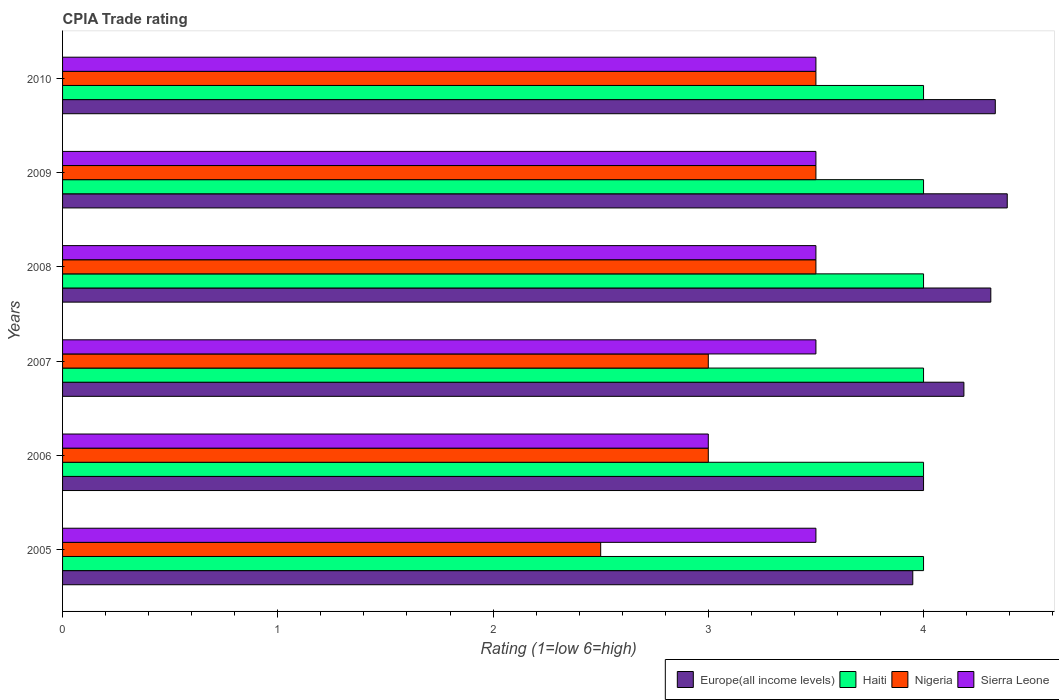How many groups of bars are there?
Your answer should be compact. 6. How many bars are there on the 6th tick from the bottom?
Make the answer very short. 4. What is the CPIA rating in Sierra Leone in 2007?
Your answer should be very brief. 3.5. Across all years, what is the maximum CPIA rating in Sierra Leone?
Your answer should be compact. 3.5. Across all years, what is the minimum CPIA rating in Haiti?
Make the answer very short. 4. In which year was the CPIA rating in Europe(all income levels) maximum?
Offer a very short reply. 2009. What is the total CPIA rating in Europe(all income levels) in the graph?
Keep it short and to the point. 25.17. What is the difference between the CPIA rating in Haiti in 2008 and that in 2009?
Provide a short and direct response. 0. What is the difference between the CPIA rating in Haiti in 2006 and the CPIA rating in Sierra Leone in 2009?
Keep it short and to the point. 0.5. What is the average CPIA rating in Europe(all income levels) per year?
Give a very brief answer. 4.2. In the year 2009, what is the difference between the CPIA rating in Nigeria and CPIA rating in Europe(all income levels)?
Give a very brief answer. -0.89. In how many years, is the CPIA rating in Haiti greater than 2 ?
Keep it short and to the point. 6. What is the ratio of the CPIA rating in Nigeria in 2007 to that in 2010?
Provide a short and direct response. 0.86. Is the CPIA rating in Haiti in 2006 less than that in 2007?
Ensure brevity in your answer.  No. Is the difference between the CPIA rating in Nigeria in 2006 and 2010 greater than the difference between the CPIA rating in Europe(all income levels) in 2006 and 2010?
Make the answer very short. No. What is the difference between the highest and the second highest CPIA rating in Sierra Leone?
Provide a succinct answer. 0. What is the difference between the highest and the lowest CPIA rating in Europe(all income levels)?
Provide a short and direct response. 0.44. Is the sum of the CPIA rating in Haiti in 2005 and 2006 greater than the maximum CPIA rating in Europe(all income levels) across all years?
Ensure brevity in your answer.  Yes. What does the 4th bar from the top in 2009 represents?
Offer a very short reply. Europe(all income levels). What does the 3rd bar from the bottom in 2010 represents?
Your response must be concise. Nigeria. Is it the case that in every year, the sum of the CPIA rating in Haiti and CPIA rating in Nigeria is greater than the CPIA rating in Europe(all income levels)?
Give a very brief answer. Yes. Are all the bars in the graph horizontal?
Offer a very short reply. Yes. How many years are there in the graph?
Offer a very short reply. 6. What is the difference between two consecutive major ticks on the X-axis?
Ensure brevity in your answer.  1. Are the values on the major ticks of X-axis written in scientific E-notation?
Provide a succinct answer. No. Does the graph contain any zero values?
Ensure brevity in your answer.  No. Where does the legend appear in the graph?
Ensure brevity in your answer.  Bottom right. What is the title of the graph?
Your response must be concise. CPIA Trade rating. Does "Latvia" appear as one of the legend labels in the graph?
Offer a very short reply. No. What is the Rating (1=low 6=high) in Europe(all income levels) in 2005?
Make the answer very short. 3.95. What is the Rating (1=low 6=high) of Europe(all income levels) in 2006?
Give a very brief answer. 4. What is the Rating (1=low 6=high) of Nigeria in 2006?
Your response must be concise. 3. What is the Rating (1=low 6=high) of Sierra Leone in 2006?
Make the answer very short. 3. What is the Rating (1=low 6=high) in Europe(all income levels) in 2007?
Offer a terse response. 4.19. What is the Rating (1=low 6=high) in Haiti in 2007?
Your answer should be very brief. 4. What is the Rating (1=low 6=high) of Sierra Leone in 2007?
Keep it short and to the point. 3.5. What is the Rating (1=low 6=high) in Europe(all income levels) in 2008?
Provide a succinct answer. 4.31. What is the Rating (1=low 6=high) in Nigeria in 2008?
Your response must be concise. 3.5. What is the Rating (1=low 6=high) in Europe(all income levels) in 2009?
Keep it short and to the point. 4.39. What is the Rating (1=low 6=high) in Sierra Leone in 2009?
Your answer should be compact. 3.5. What is the Rating (1=low 6=high) of Europe(all income levels) in 2010?
Make the answer very short. 4.33. What is the Rating (1=low 6=high) in Haiti in 2010?
Your answer should be very brief. 4. What is the Rating (1=low 6=high) of Nigeria in 2010?
Keep it short and to the point. 3.5. What is the Rating (1=low 6=high) in Sierra Leone in 2010?
Ensure brevity in your answer.  3.5. Across all years, what is the maximum Rating (1=low 6=high) of Europe(all income levels)?
Make the answer very short. 4.39. Across all years, what is the maximum Rating (1=low 6=high) in Sierra Leone?
Give a very brief answer. 3.5. Across all years, what is the minimum Rating (1=low 6=high) of Europe(all income levels)?
Your response must be concise. 3.95. Across all years, what is the minimum Rating (1=low 6=high) in Nigeria?
Give a very brief answer. 2.5. Across all years, what is the minimum Rating (1=low 6=high) in Sierra Leone?
Offer a terse response. 3. What is the total Rating (1=low 6=high) in Europe(all income levels) in the graph?
Your response must be concise. 25.17. What is the difference between the Rating (1=low 6=high) in Haiti in 2005 and that in 2006?
Keep it short and to the point. 0. What is the difference between the Rating (1=low 6=high) of Nigeria in 2005 and that in 2006?
Give a very brief answer. -0.5. What is the difference between the Rating (1=low 6=high) in Europe(all income levels) in 2005 and that in 2007?
Give a very brief answer. -0.24. What is the difference between the Rating (1=low 6=high) in Haiti in 2005 and that in 2007?
Keep it short and to the point. 0. What is the difference between the Rating (1=low 6=high) of Europe(all income levels) in 2005 and that in 2008?
Offer a very short reply. -0.36. What is the difference between the Rating (1=low 6=high) of Haiti in 2005 and that in 2008?
Offer a terse response. 0. What is the difference between the Rating (1=low 6=high) in Sierra Leone in 2005 and that in 2008?
Keep it short and to the point. 0. What is the difference between the Rating (1=low 6=high) of Europe(all income levels) in 2005 and that in 2009?
Offer a terse response. -0.44. What is the difference between the Rating (1=low 6=high) in Nigeria in 2005 and that in 2009?
Your answer should be compact. -1. What is the difference between the Rating (1=low 6=high) in Europe(all income levels) in 2005 and that in 2010?
Provide a succinct answer. -0.38. What is the difference between the Rating (1=low 6=high) in Sierra Leone in 2005 and that in 2010?
Your response must be concise. 0. What is the difference between the Rating (1=low 6=high) in Europe(all income levels) in 2006 and that in 2007?
Offer a terse response. -0.19. What is the difference between the Rating (1=low 6=high) in Haiti in 2006 and that in 2007?
Keep it short and to the point. 0. What is the difference between the Rating (1=low 6=high) of Nigeria in 2006 and that in 2007?
Keep it short and to the point. 0. What is the difference between the Rating (1=low 6=high) of Sierra Leone in 2006 and that in 2007?
Your response must be concise. -0.5. What is the difference between the Rating (1=low 6=high) in Europe(all income levels) in 2006 and that in 2008?
Ensure brevity in your answer.  -0.31. What is the difference between the Rating (1=low 6=high) in Haiti in 2006 and that in 2008?
Offer a very short reply. 0. What is the difference between the Rating (1=low 6=high) of Europe(all income levels) in 2006 and that in 2009?
Give a very brief answer. -0.39. What is the difference between the Rating (1=low 6=high) in Haiti in 2006 and that in 2009?
Your response must be concise. 0. What is the difference between the Rating (1=low 6=high) in Europe(all income levels) in 2007 and that in 2008?
Ensure brevity in your answer.  -0.12. What is the difference between the Rating (1=low 6=high) of Haiti in 2007 and that in 2008?
Provide a succinct answer. 0. What is the difference between the Rating (1=low 6=high) in Sierra Leone in 2007 and that in 2008?
Offer a terse response. 0. What is the difference between the Rating (1=low 6=high) of Europe(all income levels) in 2007 and that in 2009?
Make the answer very short. -0.2. What is the difference between the Rating (1=low 6=high) of Nigeria in 2007 and that in 2009?
Provide a short and direct response. -0.5. What is the difference between the Rating (1=low 6=high) in Europe(all income levels) in 2007 and that in 2010?
Offer a terse response. -0.15. What is the difference between the Rating (1=low 6=high) of Haiti in 2007 and that in 2010?
Make the answer very short. 0. What is the difference between the Rating (1=low 6=high) in Nigeria in 2007 and that in 2010?
Your response must be concise. -0.5. What is the difference between the Rating (1=low 6=high) of Europe(all income levels) in 2008 and that in 2009?
Provide a succinct answer. -0.08. What is the difference between the Rating (1=low 6=high) of Haiti in 2008 and that in 2009?
Make the answer very short. 0. What is the difference between the Rating (1=low 6=high) of Nigeria in 2008 and that in 2009?
Ensure brevity in your answer.  0. What is the difference between the Rating (1=low 6=high) in Sierra Leone in 2008 and that in 2009?
Ensure brevity in your answer.  0. What is the difference between the Rating (1=low 6=high) of Europe(all income levels) in 2008 and that in 2010?
Make the answer very short. -0.02. What is the difference between the Rating (1=low 6=high) in Nigeria in 2008 and that in 2010?
Your answer should be compact. 0. What is the difference between the Rating (1=low 6=high) in Europe(all income levels) in 2009 and that in 2010?
Ensure brevity in your answer.  0.06. What is the difference between the Rating (1=low 6=high) in Haiti in 2009 and that in 2010?
Your answer should be compact. 0. What is the difference between the Rating (1=low 6=high) of Nigeria in 2009 and that in 2010?
Give a very brief answer. 0. What is the difference between the Rating (1=low 6=high) of Europe(all income levels) in 2005 and the Rating (1=low 6=high) of Haiti in 2006?
Your answer should be very brief. -0.05. What is the difference between the Rating (1=low 6=high) of Europe(all income levels) in 2005 and the Rating (1=low 6=high) of Nigeria in 2006?
Your response must be concise. 0.95. What is the difference between the Rating (1=low 6=high) in Haiti in 2005 and the Rating (1=low 6=high) in Nigeria in 2006?
Keep it short and to the point. 1. What is the difference between the Rating (1=low 6=high) in Haiti in 2005 and the Rating (1=low 6=high) in Sierra Leone in 2006?
Your response must be concise. 1. What is the difference between the Rating (1=low 6=high) in Europe(all income levels) in 2005 and the Rating (1=low 6=high) in Nigeria in 2007?
Your answer should be very brief. 0.95. What is the difference between the Rating (1=low 6=high) in Europe(all income levels) in 2005 and the Rating (1=low 6=high) in Sierra Leone in 2007?
Offer a very short reply. 0.45. What is the difference between the Rating (1=low 6=high) in Europe(all income levels) in 2005 and the Rating (1=low 6=high) in Nigeria in 2008?
Your answer should be compact. 0.45. What is the difference between the Rating (1=low 6=high) of Europe(all income levels) in 2005 and the Rating (1=low 6=high) of Sierra Leone in 2008?
Give a very brief answer. 0.45. What is the difference between the Rating (1=low 6=high) of Haiti in 2005 and the Rating (1=low 6=high) of Nigeria in 2008?
Give a very brief answer. 0.5. What is the difference between the Rating (1=low 6=high) of Haiti in 2005 and the Rating (1=low 6=high) of Sierra Leone in 2008?
Keep it short and to the point. 0.5. What is the difference between the Rating (1=low 6=high) of Nigeria in 2005 and the Rating (1=low 6=high) of Sierra Leone in 2008?
Give a very brief answer. -1. What is the difference between the Rating (1=low 6=high) in Europe(all income levels) in 2005 and the Rating (1=low 6=high) in Nigeria in 2009?
Offer a terse response. 0.45. What is the difference between the Rating (1=low 6=high) in Europe(all income levels) in 2005 and the Rating (1=low 6=high) in Sierra Leone in 2009?
Offer a terse response. 0.45. What is the difference between the Rating (1=low 6=high) in Haiti in 2005 and the Rating (1=low 6=high) in Nigeria in 2009?
Provide a short and direct response. 0.5. What is the difference between the Rating (1=low 6=high) of Haiti in 2005 and the Rating (1=low 6=high) of Sierra Leone in 2009?
Provide a succinct answer. 0.5. What is the difference between the Rating (1=low 6=high) of Nigeria in 2005 and the Rating (1=low 6=high) of Sierra Leone in 2009?
Provide a succinct answer. -1. What is the difference between the Rating (1=low 6=high) of Europe(all income levels) in 2005 and the Rating (1=low 6=high) of Nigeria in 2010?
Make the answer very short. 0.45. What is the difference between the Rating (1=low 6=high) in Europe(all income levels) in 2005 and the Rating (1=low 6=high) in Sierra Leone in 2010?
Your answer should be very brief. 0.45. What is the difference between the Rating (1=low 6=high) in Haiti in 2005 and the Rating (1=low 6=high) in Nigeria in 2010?
Your answer should be very brief. 0.5. What is the difference between the Rating (1=low 6=high) of Nigeria in 2005 and the Rating (1=low 6=high) of Sierra Leone in 2010?
Your answer should be compact. -1. What is the difference between the Rating (1=low 6=high) of Europe(all income levels) in 2006 and the Rating (1=low 6=high) of Nigeria in 2007?
Your response must be concise. 1. What is the difference between the Rating (1=low 6=high) of Europe(all income levels) in 2006 and the Rating (1=low 6=high) of Sierra Leone in 2007?
Ensure brevity in your answer.  0.5. What is the difference between the Rating (1=low 6=high) in Haiti in 2006 and the Rating (1=low 6=high) in Nigeria in 2007?
Offer a terse response. 1. What is the difference between the Rating (1=low 6=high) of Nigeria in 2006 and the Rating (1=low 6=high) of Sierra Leone in 2007?
Your answer should be very brief. -0.5. What is the difference between the Rating (1=low 6=high) of Europe(all income levels) in 2006 and the Rating (1=low 6=high) of Sierra Leone in 2008?
Your answer should be compact. 0.5. What is the difference between the Rating (1=low 6=high) of Haiti in 2006 and the Rating (1=low 6=high) of Sierra Leone in 2008?
Offer a very short reply. 0.5. What is the difference between the Rating (1=low 6=high) in Nigeria in 2006 and the Rating (1=low 6=high) in Sierra Leone in 2008?
Your answer should be very brief. -0.5. What is the difference between the Rating (1=low 6=high) in Europe(all income levels) in 2006 and the Rating (1=low 6=high) in Nigeria in 2009?
Ensure brevity in your answer.  0.5. What is the difference between the Rating (1=low 6=high) in Haiti in 2006 and the Rating (1=low 6=high) in Nigeria in 2009?
Provide a short and direct response. 0.5. What is the difference between the Rating (1=low 6=high) of Haiti in 2006 and the Rating (1=low 6=high) of Sierra Leone in 2009?
Provide a succinct answer. 0.5. What is the difference between the Rating (1=low 6=high) of Nigeria in 2006 and the Rating (1=low 6=high) of Sierra Leone in 2009?
Provide a short and direct response. -0.5. What is the difference between the Rating (1=low 6=high) in Europe(all income levels) in 2006 and the Rating (1=low 6=high) in Haiti in 2010?
Keep it short and to the point. 0. What is the difference between the Rating (1=low 6=high) in Haiti in 2006 and the Rating (1=low 6=high) in Nigeria in 2010?
Provide a short and direct response. 0.5. What is the difference between the Rating (1=low 6=high) in Europe(all income levels) in 2007 and the Rating (1=low 6=high) in Haiti in 2008?
Your response must be concise. 0.19. What is the difference between the Rating (1=low 6=high) of Europe(all income levels) in 2007 and the Rating (1=low 6=high) of Nigeria in 2008?
Ensure brevity in your answer.  0.69. What is the difference between the Rating (1=low 6=high) in Europe(all income levels) in 2007 and the Rating (1=low 6=high) in Sierra Leone in 2008?
Offer a very short reply. 0.69. What is the difference between the Rating (1=low 6=high) of Haiti in 2007 and the Rating (1=low 6=high) of Nigeria in 2008?
Make the answer very short. 0.5. What is the difference between the Rating (1=low 6=high) of Haiti in 2007 and the Rating (1=low 6=high) of Sierra Leone in 2008?
Your response must be concise. 0.5. What is the difference between the Rating (1=low 6=high) of Nigeria in 2007 and the Rating (1=low 6=high) of Sierra Leone in 2008?
Your answer should be compact. -0.5. What is the difference between the Rating (1=low 6=high) in Europe(all income levels) in 2007 and the Rating (1=low 6=high) in Haiti in 2009?
Ensure brevity in your answer.  0.19. What is the difference between the Rating (1=low 6=high) in Europe(all income levels) in 2007 and the Rating (1=low 6=high) in Nigeria in 2009?
Keep it short and to the point. 0.69. What is the difference between the Rating (1=low 6=high) of Europe(all income levels) in 2007 and the Rating (1=low 6=high) of Sierra Leone in 2009?
Offer a terse response. 0.69. What is the difference between the Rating (1=low 6=high) of Haiti in 2007 and the Rating (1=low 6=high) of Nigeria in 2009?
Your answer should be very brief. 0.5. What is the difference between the Rating (1=low 6=high) of Haiti in 2007 and the Rating (1=low 6=high) of Sierra Leone in 2009?
Ensure brevity in your answer.  0.5. What is the difference between the Rating (1=low 6=high) of Nigeria in 2007 and the Rating (1=low 6=high) of Sierra Leone in 2009?
Your answer should be very brief. -0.5. What is the difference between the Rating (1=low 6=high) of Europe(all income levels) in 2007 and the Rating (1=low 6=high) of Haiti in 2010?
Offer a very short reply. 0.19. What is the difference between the Rating (1=low 6=high) in Europe(all income levels) in 2007 and the Rating (1=low 6=high) in Nigeria in 2010?
Make the answer very short. 0.69. What is the difference between the Rating (1=low 6=high) in Europe(all income levels) in 2007 and the Rating (1=low 6=high) in Sierra Leone in 2010?
Ensure brevity in your answer.  0.69. What is the difference between the Rating (1=low 6=high) in Haiti in 2007 and the Rating (1=low 6=high) in Nigeria in 2010?
Your answer should be very brief. 0.5. What is the difference between the Rating (1=low 6=high) in Nigeria in 2007 and the Rating (1=low 6=high) in Sierra Leone in 2010?
Your answer should be very brief. -0.5. What is the difference between the Rating (1=low 6=high) of Europe(all income levels) in 2008 and the Rating (1=low 6=high) of Haiti in 2009?
Your answer should be very brief. 0.31. What is the difference between the Rating (1=low 6=high) in Europe(all income levels) in 2008 and the Rating (1=low 6=high) in Nigeria in 2009?
Offer a very short reply. 0.81. What is the difference between the Rating (1=low 6=high) in Europe(all income levels) in 2008 and the Rating (1=low 6=high) in Sierra Leone in 2009?
Provide a succinct answer. 0.81. What is the difference between the Rating (1=low 6=high) in Haiti in 2008 and the Rating (1=low 6=high) in Nigeria in 2009?
Keep it short and to the point. 0.5. What is the difference between the Rating (1=low 6=high) in Nigeria in 2008 and the Rating (1=low 6=high) in Sierra Leone in 2009?
Your answer should be compact. 0. What is the difference between the Rating (1=low 6=high) of Europe(all income levels) in 2008 and the Rating (1=low 6=high) of Haiti in 2010?
Give a very brief answer. 0.31. What is the difference between the Rating (1=low 6=high) in Europe(all income levels) in 2008 and the Rating (1=low 6=high) in Nigeria in 2010?
Your answer should be very brief. 0.81. What is the difference between the Rating (1=low 6=high) of Europe(all income levels) in 2008 and the Rating (1=low 6=high) of Sierra Leone in 2010?
Make the answer very short. 0.81. What is the difference between the Rating (1=low 6=high) in Haiti in 2008 and the Rating (1=low 6=high) in Sierra Leone in 2010?
Give a very brief answer. 0.5. What is the difference between the Rating (1=low 6=high) in Nigeria in 2008 and the Rating (1=low 6=high) in Sierra Leone in 2010?
Your response must be concise. 0. What is the difference between the Rating (1=low 6=high) of Europe(all income levels) in 2009 and the Rating (1=low 6=high) of Haiti in 2010?
Your response must be concise. 0.39. What is the difference between the Rating (1=low 6=high) in Europe(all income levels) in 2009 and the Rating (1=low 6=high) in Nigeria in 2010?
Your response must be concise. 0.89. What is the difference between the Rating (1=low 6=high) of Europe(all income levels) in 2009 and the Rating (1=low 6=high) of Sierra Leone in 2010?
Ensure brevity in your answer.  0.89. What is the difference between the Rating (1=low 6=high) of Haiti in 2009 and the Rating (1=low 6=high) of Nigeria in 2010?
Offer a very short reply. 0.5. What is the difference between the Rating (1=low 6=high) in Haiti in 2009 and the Rating (1=low 6=high) in Sierra Leone in 2010?
Provide a succinct answer. 0.5. What is the average Rating (1=low 6=high) in Europe(all income levels) per year?
Your response must be concise. 4.2. What is the average Rating (1=low 6=high) in Nigeria per year?
Offer a very short reply. 3.17. What is the average Rating (1=low 6=high) of Sierra Leone per year?
Your answer should be compact. 3.42. In the year 2005, what is the difference between the Rating (1=low 6=high) of Europe(all income levels) and Rating (1=low 6=high) of Nigeria?
Your answer should be very brief. 1.45. In the year 2005, what is the difference between the Rating (1=low 6=high) in Europe(all income levels) and Rating (1=low 6=high) in Sierra Leone?
Provide a succinct answer. 0.45. In the year 2005, what is the difference between the Rating (1=low 6=high) in Haiti and Rating (1=low 6=high) in Nigeria?
Your response must be concise. 1.5. In the year 2005, what is the difference between the Rating (1=low 6=high) in Nigeria and Rating (1=low 6=high) in Sierra Leone?
Your answer should be compact. -1. In the year 2006, what is the difference between the Rating (1=low 6=high) of Europe(all income levels) and Rating (1=low 6=high) of Nigeria?
Give a very brief answer. 1. In the year 2006, what is the difference between the Rating (1=low 6=high) of Haiti and Rating (1=low 6=high) of Sierra Leone?
Your answer should be compact. 1. In the year 2007, what is the difference between the Rating (1=low 6=high) of Europe(all income levels) and Rating (1=low 6=high) of Haiti?
Provide a short and direct response. 0.19. In the year 2007, what is the difference between the Rating (1=low 6=high) of Europe(all income levels) and Rating (1=low 6=high) of Nigeria?
Your answer should be very brief. 1.19. In the year 2007, what is the difference between the Rating (1=low 6=high) in Europe(all income levels) and Rating (1=low 6=high) in Sierra Leone?
Provide a succinct answer. 0.69. In the year 2007, what is the difference between the Rating (1=low 6=high) of Haiti and Rating (1=low 6=high) of Sierra Leone?
Keep it short and to the point. 0.5. In the year 2008, what is the difference between the Rating (1=low 6=high) in Europe(all income levels) and Rating (1=low 6=high) in Haiti?
Keep it short and to the point. 0.31. In the year 2008, what is the difference between the Rating (1=low 6=high) of Europe(all income levels) and Rating (1=low 6=high) of Nigeria?
Offer a terse response. 0.81. In the year 2008, what is the difference between the Rating (1=low 6=high) in Europe(all income levels) and Rating (1=low 6=high) in Sierra Leone?
Provide a short and direct response. 0.81. In the year 2008, what is the difference between the Rating (1=low 6=high) in Haiti and Rating (1=low 6=high) in Nigeria?
Give a very brief answer. 0.5. In the year 2009, what is the difference between the Rating (1=low 6=high) of Europe(all income levels) and Rating (1=low 6=high) of Haiti?
Offer a very short reply. 0.39. In the year 2009, what is the difference between the Rating (1=low 6=high) in Europe(all income levels) and Rating (1=low 6=high) in Sierra Leone?
Make the answer very short. 0.89. In the year 2009, what is the difference between the Rating (1=low 6=high) in Nigeria and Rating (1=low 6=high) in Sierra Leone?
Provide a short and direct response. 0. In the year 2010, what is the difference between the Rating (1=low 6=high) in Europe(all income levels) and Rating (1=low 6=high) in Haiti?
Ensure brevity in your answer.  0.33. In the year 2010, what is the difference between the Rating (1=low 6=high) of Nigeria and Rating (1=low 6=high) of Sierra Leone?
Offer a very short reply. 0. What is the ratio of the Rating (1=low 6=high) of Europe(all income levels) in 2005 to that in 2006?
Ensure brevity in your answer.  0.99. What is the ratio of the Rating (1=low 6=high) in Haiti in 2005 to that in 2006?
Your answer should be compact. 1. What is the ratio of the Rating (1=low 6=high) of Nigeria in 2005 to that in 2006?
Keep it short and to the point. 0.83. What is the ratio of the Rating (1=low 6=high) in Sierra Leone in 2005 to that in 2006?
Your response must be concise. 1.17. What is the ratio of the Rating (1=low 6=high) of Europe(all income levels) in 2005 to that in 2007?
Make the answer very short. 0.94. What is the ratio of the Rating (1=low 6=high) in Haiti in 2005 to that in 2007?
Provide a succinct answer. 1. What is the ratio of the Rating (1=low 6=high) of Europe(all income levels) in 2005 to that in 2008?
Make the answer very short. 0.92. What is the ratio of the Rating (1=low 6=high) in Haiti in 2005 to that in 2008?
Offer a very short reply. 1. What is the ratio of the Rating (1=low 6=high) in Sierra Leone in 2005 to that in 2008?
Your response must be concise. 1. What is the ratio of the Rating (1=low 6=high) in Europe(all income levels) in 2005 to that in 2009?
Provide a succinct answer. 0.9. What is the ratio of the Rating (1=low 6=high) of Nigeria in 2005 to that in 2009?
Give a very brief answer. 0.71. What is the ratio of the Rating (1=low 6=high) in Europe(all income levels) in 2005 to that in 2010?
Provide a succinct answer. 0.91. What is the ratio of the Rating (1=low 6=high) in Haiti in 2005 to that in 2010?
Your response must be concise. 1. What is the ratio of the Rating (1=low 6=high) in Nigeria in 2005 to that in 2010?
Make the answer very short. 0.71. What is the ratio of the Rating (1=low 6=high) in Sierra Leone in 2005 to that in 2010?
Offer a terse response. 1. What is the ratio of the Rating (1=low 6=high) in Europe(all income levels) in 2006 to that in 2007?
Give a very brief answer. 0.96. What is the ratio of the Rating (1=low 6=high) in Haiti in 2006 to that in 2007?
Your answer should be very brief. 1. What is the ratio of the Rating (1=low 6=high) in Nigeria in 2006 to that in 2007?
Offer a very short reply. 1. What is the ratio of the Rating (1=low 6=high) in Sierra Leone in 2006 to that in 2007?
Offer a very short reply. 0.86. What is the ratio of the Rating (1=low 6=high) of Europe(all income levels) in 2006 to that in 2008?
Offer a very short reply. 0.93. What is the ratio of the Rating (1=low 6=high) of Haiti in 2006 to that in 2008?
Give a very brief answer. 1. What is the ratio of the Rating (1=low 6=high) of Nigeria in 2006 to that in 2008?
Give a very brief answer. 0.86. What is the ratio of the Rating (1=low 6=high) in Europe(all income levels) in 2006 to that in 2009?
Keep it short and to the point. 0.91. What is the ratio of the Rating (1=low 6=high) of Nigeria in 2006 to that in 2009?
Your answer should be compact. 0.86. What is the ratio of the Rating (1=low 6=high) of Europe(all income levels) in 2006 to that in 2010?
Keep it short and to the point. 0.92. What is the ratio of the Rating (1=low 6=high) of Europe(all income levels) in 2007 to that in 2008?
Make the answer very short. 0.97. What is the ratio of the Rating (1=low 6=high) of Haiti in 2007 to that in 2008?
Make the answer very short. 1. What is the ratio of the Rating (1=low 6=high) in Nigeria in 2007 to that in 2008?
Your response must be concise. 0.86. What is the ratio of the Rating (1=low 6=high) of Sierra Leone in 2007 to that in 2008?
Ensure brevity in your answer.  1. What is the ratio of the Rating (1=low 6=high) of Europe(all income levels) in 2007 to that in 2009?
Your answer should be very brief. 0.95. What is the ratio of the Rating (1=low 6=high) in Haiti in 2007 to that in 2009?
Offer a terse response. 1. What is the ratio of the Rating (1=low 6=high) of Europe(all income levels) in 2007 to that in 2010?
Keep it short and to the point. 0.97. What is the ratio of the Rating (1=low 6=high) in Haiti in 2007 to that in 2010?
Give a very brief answer. 1. What is the ratio of the Rating (1=low 6=high) in Sierra Leone in 2007 to that in 2010?
Give a very brief answer. 1. What is the ratio of the Rating (1=low 6=high) in Europe(all income levels) in 2008 to that in 2009?
Ensure brevity in your answer.  0.98. What is the ratio of the Rating (1=low 6=high) in Haiti in 2008 to that in 2009?
Your answer should be very brief. 1. What is the ratio of the Rating (1=low 6=high) in Nigeria in 2008 to that in 2009?
Provide a succinct answer. 1. What is the ratio of the Rating (1=low 6=high) of Sierra Leone in 2008 to that in 2009?
Ensure brevity in your answer.  1. What is the ratio of the Rating (1=low 6=high) in Nigeria in 2008 to that in 2010?
Your answer should be very brief. 1. What is the ratio of the Rating (1=low 6=high) of Sierra Leone in 2008 to that in 2010?
Keep it short and to the point. 1. What is the ratio of the Rating (1=low 6=high) of Europe(all income levels) in 2009 to that in 2010?
Provide a short and direct response. 1.01. What is the difference between the highest and the second highest Rating (1=low 6=high) of Europe(all income levels)?
Ensure brevity in your answer.  0.06. What is the difference between the highest and the second highest Rating (1=low 6=high) in Nigeria?
Make the answer very short. 0. What is the difference between the highest and the lowest Rating (1=low 6=high) in Europe(all income levels)?
Your response must be concise. 0.44. What is the difference between the highest and the lowest Rating (1=low 6=high) of Haiti?
Provide a short and direct response. 0. What is the difference between the highest and the lowest Rating (1=low 6=high) of Nigeria?
Offer a terse response. 1. What is the difference between the highest and the lowest Rating (1=low 6=high) in Sierra Leone?
Your answer should be compact. 0.5. 